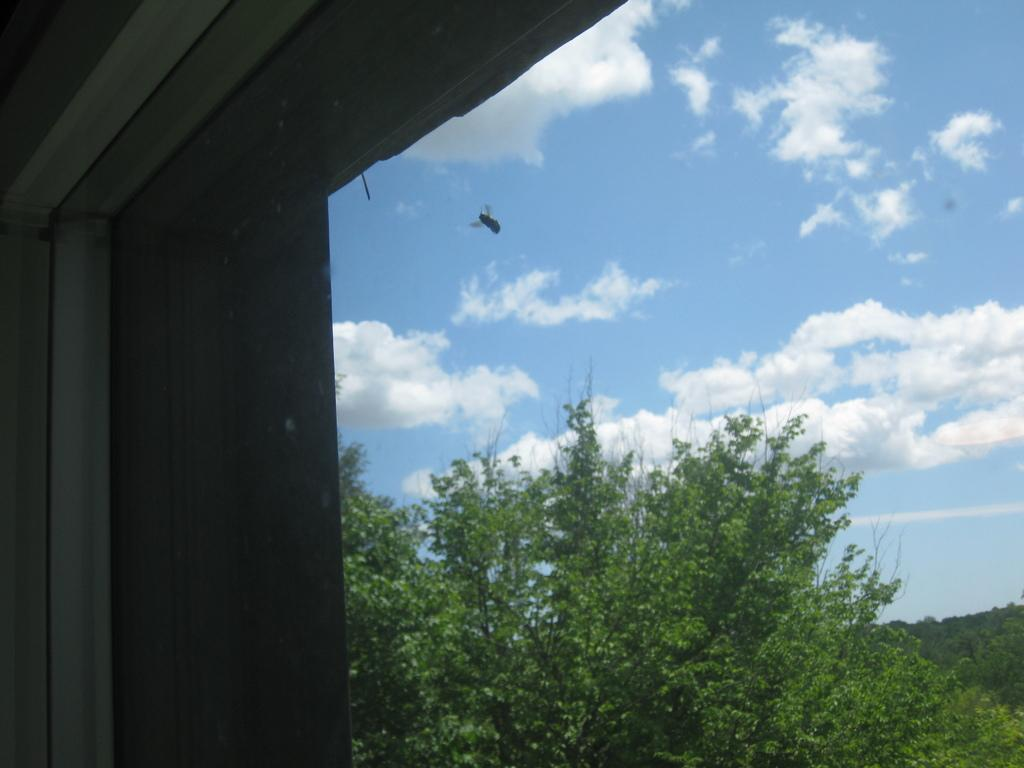What can be seen through the window in the image? Trees and an insect are visible through the window in the image. What is the condition of the sky visible through the window? The sky visible through the window is cloudy. How many people are in the crowd visible through the window? There is no crowd visible through the window in the image; it only shows trees, an insect, and the cloudy sky. 